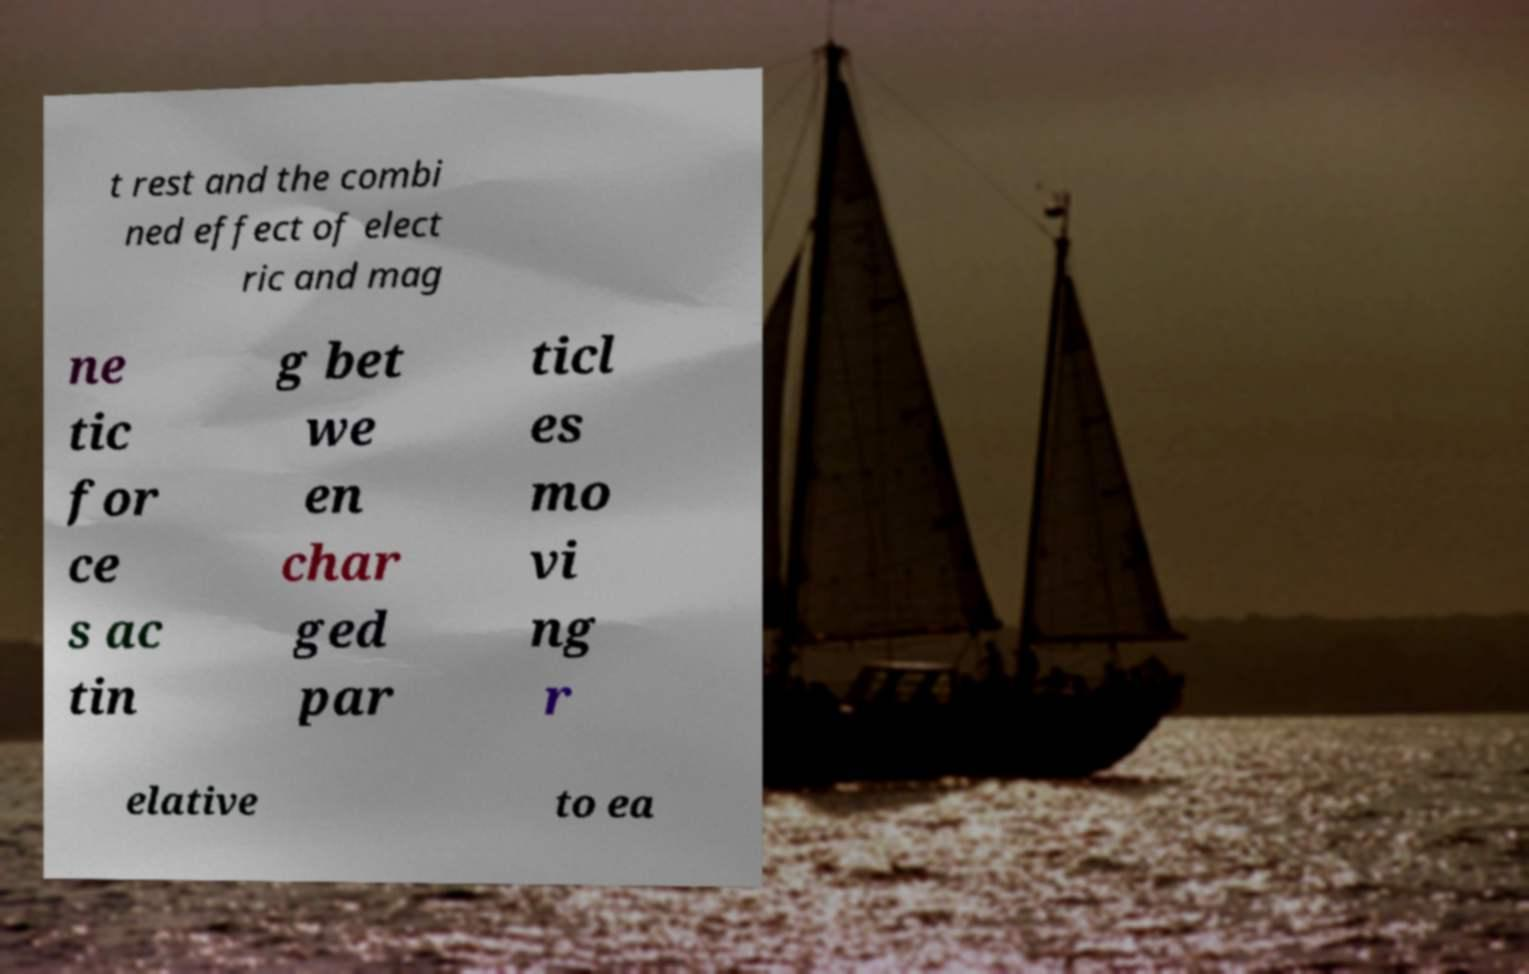Please identify and transcribe the text found in this image. t rest and the combi ned effect of elect ric and mag ne tic for ce s ac tin g bet we en char ged par ticl es mo vi ng r elative to ea 